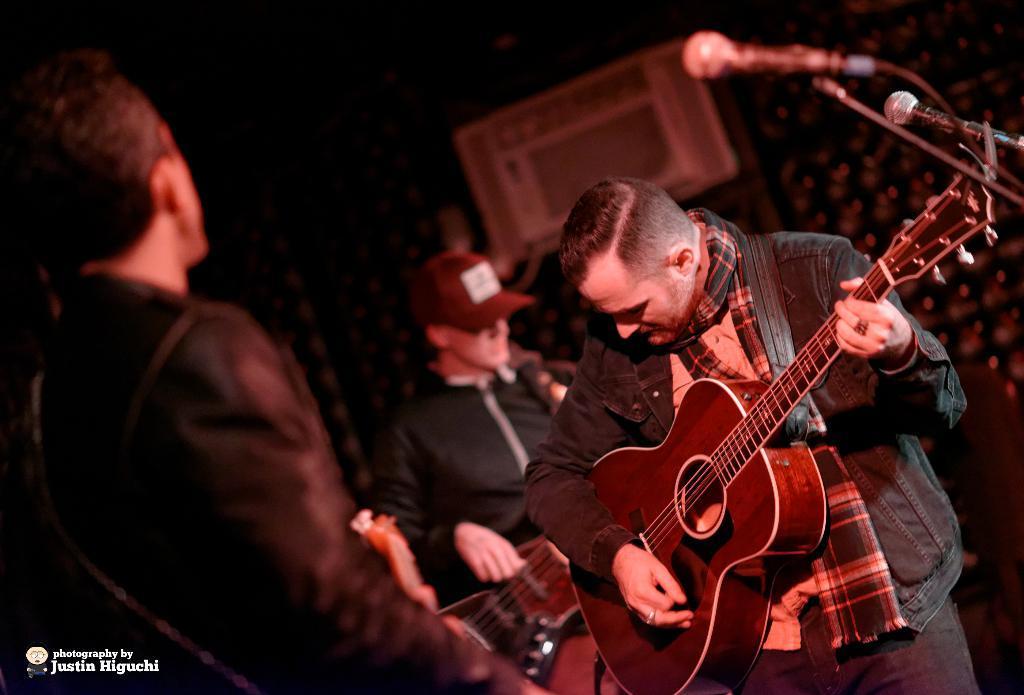How would you summarize this image in a sentence or two? In this image there are three persons. In front person is standing and playing the guitar. There is a mic and a stand. 